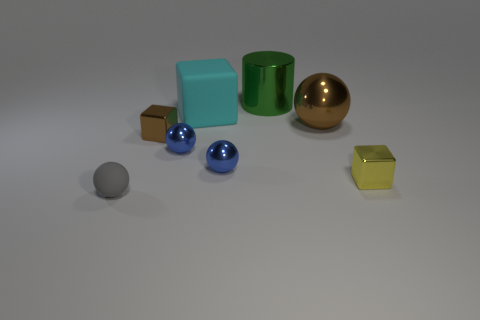Add 1 small yellow cubes. How many objects exist? 9 Subtract all cylinders. How many objects are left? 7 Subtract all purple shiny cylinders. Subtract all tiny yellow objects. How many objects are left? 7 Add 4 small spheres. How many small spheres are left? 7 Add 7 big brown spheres. How many big brown spheres exist? 8 Subtract 0 red cubes. How many objects are left? 8 